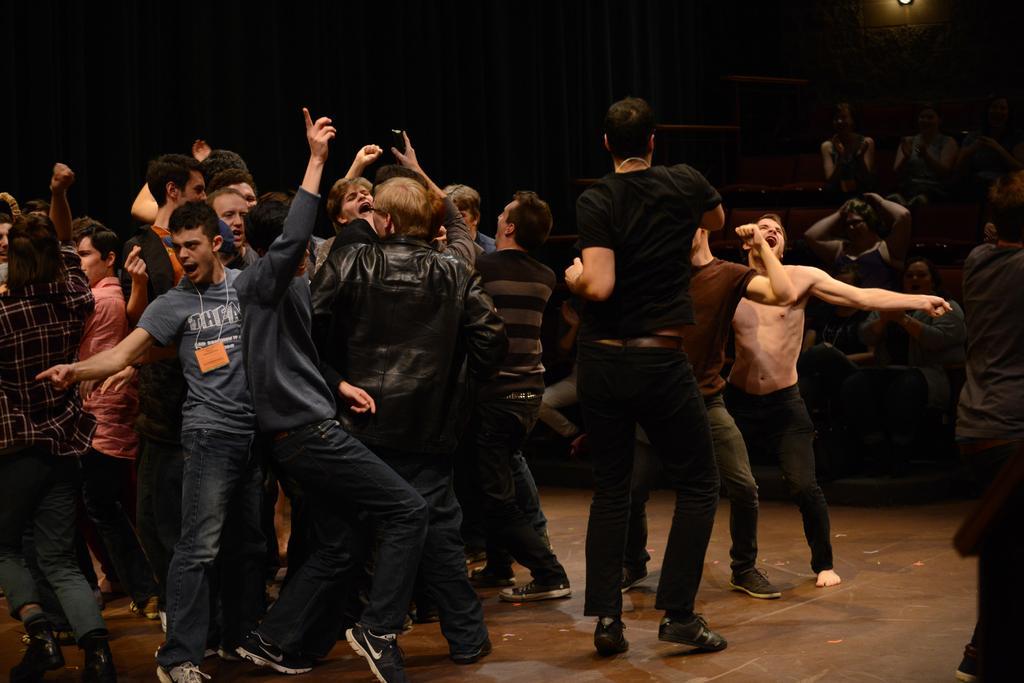Could you give a brief overview of what you see in this image? In this image I can see number of people are standing in the front. On the right side of this image I can see few more people are sitting on chairs and on the the right top corner of this image I can see a light. 